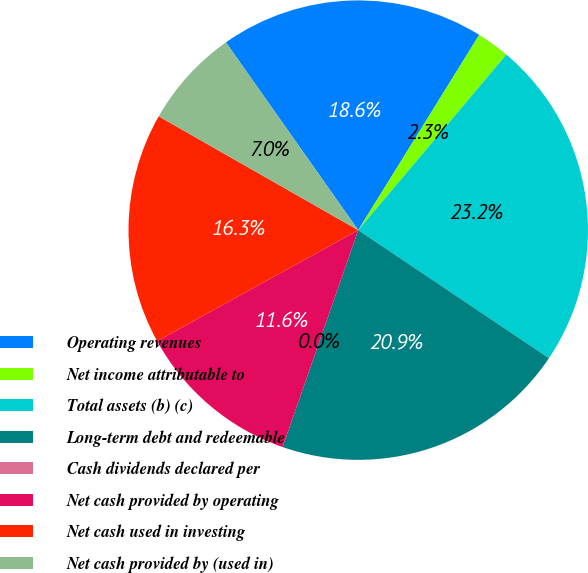<chart> <loc_0><loc_0><loc_500><loc_500><pie_chart><fcel>Operating revenues<fcel>Net income attributable to<fcel>Total assets (b) (c)<fcel>Long-term debt and redeemable<fcel>Cash dividends declared per<fcel>Net cash provided by operating<fcel>Net cash used in investing<fcel>Net cash provided by (used in)<nl><fcel>18.6%<fcel>2.33%<fcel>23.25%<fcel>20.93%<fcel>0.0%<fcel>11.63%<fcel>16.28%<fcel>6.98%<nl></chart> 